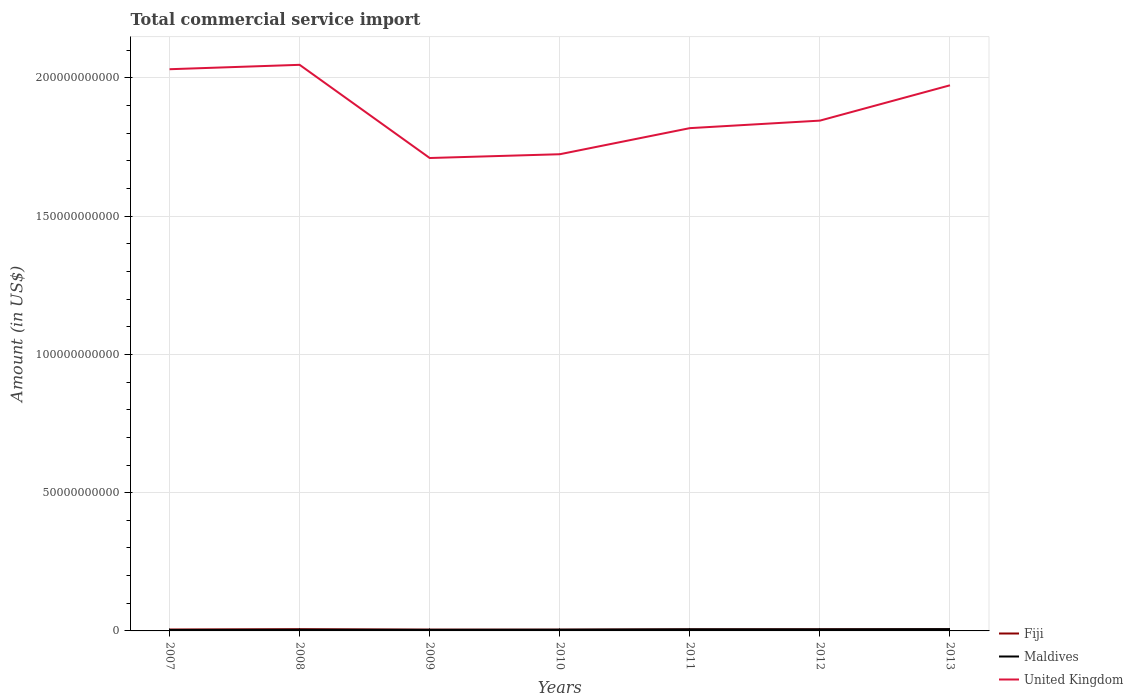How many different coloured lines are there?
Make the answer very short. 3. Is the number of lines equal to the number of legend labels?
Offer a terse response. Yes. Across all years, what is the maximum total commercial service import in Fiji?
Keep it short and to the point. 4.44e+08. In which year was the total commercial service import in United Kingdom maximum?
Your answer should be very brief. 2009. What is the total total commercial service import in United Kingdom in the graph?
Offer a terse response. 3.21e+1. What is the difference between the highest and the second highest total commercial service import in Fiji?
Provide a short and direct response. 1.78e+08. What is the difference between the highest and the lowest total commercial service import in Maldives?
Your answer should be very brief. 3. How many years are there in the graph?
Offer a terse response. 7. What is the difference between two consecutive major ticks on the Y-axis?
Give a very brief answer. 5.00e+1. Are the values on the major ticks of Y-axis written in scientific E-notation?
Offer a terse response. No. Where does the legend appear in the graph?
Offer a very short reply. Bottom right. How many legend labels are there?
Keep it short and to the point. 3. What is the title of the graph?
Provide a short and direct response. Total commercial service import. Does "Hungary" appear as one of the legend labels in the graph?
Keep it short and to the point. No. What is the label or title of the X-axis?
Provide a short and direct response. Years. What is the Amount (in US$) of Fiji in 2007?
Provide a succinct answer. 5.15e+08. What is the Amount (in US$) in Maldives in 2007?
Ensure brevity in your answer.  3.26e+08. What is the Amount (in US$) in United Kingdom in 2007?
Your response must be concise. 2.03e+11. What is the Amount (in US$) of Fiji in 2008?
Your answer should be compact. 6.22e+08. What is the Amount (in US$) in Maldives in 2008?
Your answer should be compact. 4.19e+08. What is the Amount (in US$) in United Kingdom in 2008?
Ensure brevity in your answer.  2.05e+11. What is the Amount (in US$) of Fiji in 2009?
Offer a terse response. 4.62e+08. What is the Amount (in US$) in Maldives in 2009?
Your response must be concise. 3.94e+08. What is the Amount (in US$) of United Kingdom in 2009?
Your answer should be compact. 1.71e+11. What is the Amount (in US$) of Fiji in 2010?
Your answer should be compact. 4.44e+08. What is the Amount (in US$) of Maldives in 2010?
Keep it short and to the point. 4.46e+08. What is the Amount (in US$) in United Kingdom in 2010?
Offer a very short reply. 1.72e+11. What is the Amount (in US$) of Fiji in 2011?
Ensure brevity in your answer.  5.33e+08. What is the Amount (in US$) of Maldives in 2011?
Your answer should be very brief. 5.84e+08. What is the Amount (in US$) in United Kingdom in 2011?
Your answer should be very brief. 1.82e+11. What is the Amount (in US$) of Fiji in 2012?
Keep it short and to the point. 5.62e+08. What is the Amount (in US$) in Maldives in 2012?
Your answer should be very brief. 5.72e+08. What is the Amount (in US$) of United Kingdom in 2012?
Your answer should be compact. 1.85e+11. What is the Amount (in US$) of Fiji in 2013?
Offer a terse response. 5.51e+08. What is the Amount (in US$) of Maldives in 2013?
Your response must be concise. 6.48e+08. What is the Amount (in US$) in United Kingdom in 2013?
Your answer should be very brief. 1.97e+11. Across all years, what is the maximum Amount (in US$) in Fiji?
Your answer should be very brief. 6.22e+08. Across all years, what is the maximum Amount (in US$) of Maldives?
Make the answer very short. 6.48e+08. Across all years, what is the maximum Amount (in US$) of United Kingdom?
Give a very brief answer. 2.05e+11. Across all years, what is the minimum Amount (in US$) of Fiji?
Provide a short and direct response. 4.44e+08. Across all years, what is the minimum Amount (in US$) in Maldives?
Provide a short and direct response. 3.26e+08. Across all years, what is the minimum Amount (in US$) in United Kingdom?
Your answer should be very brief. 1.71e+11. What is the total Amount (in US$) of Fiji in the graph?
Keep it short and to the point. 3.69e+09. What is the total Amount (in US$) in Maldives in the graph?
Offer a terse response. 3.39e+09. What is the total Amount (in US$) in United Kingdom in the graph?
Your answer should be very brief. 1.31e+12. What is the difference between the Amount (in US$) of Fiji in 2007 and that in 2008?
Ensure brevity in your answer.  -1.07e+08. What is the difference between the Amount (in US$) of Maldives in 2007 and that in 2008?
Offer a very short reply. -9.31e+07. What is the difference between the Amount (in US$) of United Kingdom in 2007 and that in 2008?
Provide a succinct answer. -1.59e+09. What is the difference between the Amount (in US$) in Fiji in 2007 and that in 2009?
Make the answer very short. 5.35e+07. What is the difference between the Amount (in US$) in Maldives in 2007 and that in 2009?
Offer a very short reply. -6.78e+07. What is the difference between the Amount (in US$) in United Kingdom in 2007 and that in 2009?
Provide a succinct answer. 3.21e+1. What is the difference between the Amount (in US$) of Fiji in 2007 and that in 2010?
Keep it short and to the point. 7.09e+07. What is the difference between the Amount (in US$) in Maldives in 2007 and that in 2010?
Ensure brevity in your answer.  -1.20e+08. What is the difference between the Amount (in US$) of United Kingdom in 2007 and that in 2010?
Your response must be concise. 3.07e+1. What is the difference between the Amount (in US$) of Fiji in 2007 and that in 2011?
Give a very brief answer. -1.78e+07. What is the difference between the Amount (in US$) in Maldives in 2007 and that in 2011?
Keep it short and to the point. -2.58e+08. What is the difference between the Amount (in US$) of United Kingdom in 2007 and that in 2011?
Your response must be concise. 2.13e+1. What is the difference between the Amount (in US$) in Fiji in 2007 and that in 2012?
Keep it short and to the point. -4.65e+07. What is the difference between the Amount (in US$) in Maldives in 2007 and that in 2012?
Your answer should be very brief. -2.46e+08. What is the difference between the Amount (in US$) of United Kingdom in 2007 and that in 2012?
Make the answer very short. 1.86e+1. What is the difference between the Amount (in US$) of Fiji in 2007 and that in 2013?
Offer a terse response. -3.51e+07. What is the difference between the Amount (in US$) of Maldives in 2007 and that in 2013?
Give a very brief answer. -3.21e+08. What is the difference between the Amount (in US$) in United Kingdom in 2007 and that in 2013?
Give a very brief answer. 5.81e+09. What is the difference between the Amount (in US$) of Fiji in 2008 and that in 2009?
Provide a succinct answer. 1.60e+08. What is the difference between the Amount (in US$) in Maldives in 2008 and that in 2009?
Make the answer very short. 2.53e+07. What is the difference between the Amount (in US$) in United Kingdom in 2008 and that in 2009?
Offer a terse response. 3.37e+1. What is the difference between the Amount (in US$) in Fiji in 2008 and that in 2010?
Offer a terse response. 1.78e+08. What is the difference between the Amount (in US$) of Maldives in 2008 and that in 2010?
Ensure brevity in your answer.  -2.64e+07. What is the difference between the Amount (in US$) in United Kingdom in 2008 and that in 2010?
Provide a succinct answer. 3.23e+1. What is the difference between the Amount (in US$) of Fiji in 2008 and that in 2011?
Your answer should be very brief. 8.88e+07. What is the difference between the Amount (in US$) of Maldives in 2008 and that in 2011?
Make the answer very short. -1.65e+08. What is the difference between the Amount (in US$) in United Kingdom in 2008 and that in 2011?
Provide a short and direct response. 2.29e+1. What is the difference between the Amount (in US$) of Fiji in 2008 and that in 2012?
Offer a terse response. 6.02e+07. What is the difference between the Amount (in US$) in Maldives in 2008 and that in 2012?
Offer a terse response. -1.53e+08. What is the difference between the Amount (in US$) in United Kingdom in 2008 and that in 2012?
Your response must be concise. 2.02e+1. What is the difference between the Amount (in US$) of Fiji in 2008 and that in 2013?
Your answer should be very brief. 7.15e+07. What is the difference between the Amount (in US$) in Maldives in 2008 and that in 2013?
Your answer should be very brief. -2.28e+08. What is the difference between the Amount (in US$) in United Kingdom in 2008 and that in 2013?
Offer a very short reply. 7.40e+09. What is the difference between the Amount (in US$) of Fiji in 2009 and that in 2010?
Your response must be concise. 1.74e+07. What is the difference between the Amount (in US$) of Maldives in 2009 and that in 2010?
Your response must be concise. -5.18e+07. What is the difference between the Amount (in US$) of United Kingdom in 2009 and that in 2010?
Your answer should be very brief. -1.37e+09. What is the difference between the Amount (in US$) of Fiji in 2009 and that in 2011?
Keep it short and to the point. -7.13e+07. What is the difference between the Amount (in US$) in Maldives in 2009 and that in 2011?
Your answer should be compact. -1.90e+08. What is the difference between the Amount (in US$) in United Kingdom in 2009 and that in 2011?
Your answer should be compact. -1.08e+1. What is the difference between the Amount (in US$) in Fiji in 2009 and that in 2012?
Your response must be concise. -1.00e+08. What is the difference between the Amount (in US$) in Maldives in 2009 and that in 2012?
Your answer should be compact. -1.78e+08. What is the difference between the Amount (in US$) of United Kingdom in 2009 and that in 2012?
Your answer should be compact. -1.35e+1. What is the difference between the Amount (in US$) of Fiji in 2009 and that in 2013?
Offer a very short reply. -8.86e+07. What is the difference between the Amount (in US$) in Maldives in 2009 and that in 2013?
Your answer should be very brief. -2.53e+08. What is the difference between the Amount (in US$) in United Kingdom in 2009 and that in 2013?
Your response must be concise. -2.63e+1. What is the difference between the Amount (in US$) in Fiji in 2010 and that in 2011?
Ensure brevity in your answer.  -8.88e+07. What is the difference between the Amount (in US$) of Maldives in 2010 and that in 2011?
Make the answer very short. -1.38e+08. What is the difference between the Amount (in US$) in United Kingdom in 2010 and that in 2011?
Your response must be concise. -9.43e+09. What is the difference between the Amount (in US$) of Fiji in 2010 and that in 2012?
Offer a very short reply. -1.17e+08. What is the difference between the Amount (in US$) in Maldives in 2010 and that in 2012?
Provide a short and direct response. -1.26e+08. What is the difference between the Amount (in US$) of United Kingdom in 2010 and that in 2012?
Provide a short and direct response. -1.22e+1. What is the difference between the Amount (in US$) in Fiji in 2010 and that in 2013?
Ensure brevity in your answer.  -1.06e+08. What is the difference between the Amount (in US$) in Maldives in 2010 and that in 2013?
Give a very brief answer. -2.02e+08. What is the difference between the Amount (in US$) in United Kingdom in 2010 and that in 2013?
Your response must be concise. -2.49e+1. What is the difference between the Amount (in US$) of Fiji in 2011 and that in 2012?
Ensure brevity in your answer.  -2.86e+07. What is the difference between the Amount (in US$) of Maldives in 2011 and that in 2012?
Your answer should be compact. 1.19e+07. What is the difference between the Amount (in US$) in United Kingdom in 2011 and that in 2012?
Keep it short and to the point. -2.72e+09. What is the difference between the Amount (in US$) of Fiji in 2011 and that in 2013?
Offer a terse response. -1.73e+07. What is the difference between the Amount (in US$) in Maldives in 2011 and that in 2013?
Your response must be concise. -6.36e+07. What is the difference between the Amount (in US$) in United Kingdom in 2011 and that in 2013?
Provide a short and direct response. -1.55e+1. What is the difference between the Amount (in US$) of Fiji in 2012 and that in 2013?
Your answer should be compact. 1.14e+07. What is the difference between the Amount (in US$) in Maldives in 2012 and that in 2013?
Your response must be concise. -7.55e+07. What is the difference between the Amount (in US$) of United Kingdom in 2012 and that in 2013?
Give a very brief answer. -1.28e+1. What is the difference between the Amount (in US$) of Fiji in 2007 and the Amount (in US$) of Maldives in 2008?
Your answer should be very brief. 9.59e+07. What is the difference between the Amount (in US$) in Fiji in 2007 and the Amount (in US$) in United Kingdom in 2008?
Keep it short and to the point. -2.04e+11. What is the difference between the Amount (in US$) in Maldives in 2007 and the Amount (in US$) in United Kingdom in 2008?
Offer a terse response. -2.04e+11. What is the difference between the Amount (in US$) of Fiji in 2007 and the Amount (in US$) of Maldives in 2009?
Offer a very short reply. 1.21e+08. What is the difference between the Amount (in US$) in Fiji in 2007 and the Amount (in US$) in United Kingdom in 2009?
Provide a succinct answer. -1.71e+11. What is the difference between the Amount (in US$) in Maldives in 2007 and the Amount (in US$) in United Kingdom in 2009?
Keep it short and to the point. -1.71e+11. What is the difference between the Amount (in US$) of Fiji in 2007 and the Amount (in US$) of Maldives in 2010?
Your response must be concise. 6.95e+07. What is the difference between the Amount (in US$) of Fiji in 2007 and the Amount (in US$) of United Kingdom in 2010?
Your answer should be compact. -1.72e+11. What is the difference between the Amount (in US$) in Maldives in 2007 and the Amount (in US$) in United Kingdom in 2010?
Provide a succinct answer. -1.72e+11. What is the difference between the Amount (in US$) of Fiji in 2007 and the Amount (in US$) of Maldives in 2011?
Keep it short and to the point. -6.86e+07. What is the difference between the Amount (in US$) in Fiji in 2007 and the Amount (in US$) in United Kingdom in 2011?
Provide a succinct answer. -1.81e+11. What is the difference between the Amount (in US$) of Maldives in 2007 and the Amount (in US$) of United Kingdom in 2011?
Offer a very short reply. -1.81e+11. What is the difference between the Amount (in US$) of Fiji in 2007 and the Amount (in US$) of Maldives in 2012?
Your answer should be very brief. -5.66e+07. What is the difference between the Amount (in US$) of Fiji in 2007 and the Amount (in US$) of United Kingdom in 2012?
Offer a very short reply. -1.84e+11. What is the difference between the Amount (in US$) of Maldives in 2007 and the Amount (in US$) of United Kingdom in 2012?
Give a very brief answer. -1.84e+11. What is the difference between the Amount (in US$) of Fiji in 2007 and the Amount (in US$) of Maldives in 2013?
Your answer should be very brief. -1.32e+08. What is the difference between the Amount (in US$) in Fiji in 2007 and the Amount (in US$) in United Kingdom in 2013?
Provide a short and direct response. -1.97e+11. What is the difference between the Amount (in US$) of Maldives in 2007 and the Amount (in US$) of United Kingdom in 2013?
Keep it short and to the point. -1.97e+11. What is the difference between the Amount (in US$) in Fiji in 2008 and the Amount (in US$) in Maldives in 2009?
Provide a succinct answer. 2.28e+08. What is the difference between the Amount (in US$) of Fiji in 2008 and the Amount (in US$) of United Kingdom in 2009?
Your answer should be compact. -1.70e+11. What is the difference between the Amount (in US$) in Maldives in 2008 and the Amount (in US$) in United Kingdom in 2009?
Your answer should be very brief. -1.71e+11. What is the difference between the Amount (in US$) in Fiji in 2008 and the Amount (in US$) in Maldives in 2010?
Give a very brief answer. 1.76e+08. What is the difference between the Amount (in US$) of Fiji in 2008 and the Amount (in US$) of United Kingdom in 2010?
Offer a very short reply. -1.72e+11. What is the difference between the Amount (in US$) in Maldives in 2008 and the Amount (in US$) in United Kingdom in 2010?
Provide a succinct answer. -1.72e+11. What is the difference between the Amount (in US$) of Fiji in 2008 and the Amount (in US$) of Maldives in 2011?
Offer a terse response. 3.81e+07. What is the difference between the Amount (in US$) of Fiji in 2008 and the Amount (in US$) of United Kingdom in 2011?
Your answer should be compact. -1.81e+11. What is the difference between the Amount (in US$) in Maldives in 2008 and the Amount (in US$) in United Kingdom in 2011?
Offer a very short reply. -1.81e+11. What is the difference between the Amount (in US$) in Fiji in 2008 and the Amount (in US$) in Maldives in 2012?
Your answer should be compact. 5.00e+07. What is the difference between the Amount (in US$) in Fiji in 2008 and the Amount (in US$) in United Kingdom in 2012?
Ensure brevity in your answer.  -1.84e+11. What is the difference between the Amount (in US$) in Maldives in 2008 and the Amount (in US$) in United Kingdom in 2012?
Offer a terse response. -1.84e+11. What is the difference between the Amount (in US$) in Fiji in 2008 and the Amount (in US$) in Maldives in 2013?
Your answer should be very brief. -2.55e+07. What is the difference between the Amount (in US$) in Fiji in 2008 and the Amount (in US$) in United Kingdom in 2013?
Offer a terse response. -1.97e+11. What is the difference between the Amount (in US$) in Maldives in 2008 and the Amount (in US$) in United Kingdom in 2013?
Keep it short and to the point. -1.97e+11. What is the difference between the Amount (in US$) of Fiji in 2009 and the Amount (in US$) of Maldives in 2010?
Your answer should be compact. 1.60e+07. What is the difference between the Amount (in US$) in Fiji in 2009 and the Amount (in US$) in United Kingdom in 2010?
Provide a short and direct response. -1.72e+11. What is the difference between the Amount (in US$) of Maldives in 2009 and the Amount (in US$) of United Kingdom in 2010?
Your answer should be very brief. -1.72e+11. What is the difference between the Amount (in US$) in Fiji in 2009 and the Amount (in US$) in Maldives in 2011?
Make the answer very short. -1.22e+08. What is the difference between the Amount (in US$) in Fiji in 2009 and the Amount (in US$) in United Kingdom in 2011?
Keep it short and to the point. -1.81e+11. What is the difference between the Amount (in US$) of Maldives in 2009 and the Amount (in US$) of United Kingdom in 2011?
Ensure brevity in your answer.  -1.81e+11. What is the difference between the Amount (in US$) in Fiji in 2009 and the Amount (in US$) in Maldives in 2012?
Give a very brief answer. -1.10e+08. What is the difference between the Amount (in US$) of Fiji in 2009 and the Amount (in US$) of United Kingdom in 2012?
Your answer should be very brief. -1.84e+11. What is the difference between the Amount (in US$) of Maldives in 2009 and the Amount (in US$) of United Kingdom in 2012?
Your answer should be very brief. -1.84e+11. What is the difference between the Amount (in US$) in Fiji in 2009 and the Amount (in US$) in Maldives in 2013?
Your answer should be compact. -1.86e+08. What is the difference between the Amount (in US$) of Fiji in 2009 and the Amount (in US$) of United Kingdom in 2013?
Offer a very short reply. -1.97e+11. What is the difference between the Amount (in US$) of Maldives in 2009 and the Amount (in US$) of United Kingdom in 2013?
Offer a terse response. -1.97e+11. What is the difference between the Amount (in US$) of Fiji in 2010 and the Amount (in US$) of Maldives in 2011?
Provide a short and direct response. -1.39e+08. What is the difference between the Amount (in US$) in Fiji in 2010 and the Amount (in US$) in United Kingdom in 2011?
Your answer should be compact. -1.81e+11. What is the difference between the Amount (in US$) of Maldives in 2010 and the Amount (in US$) of United Kingdom in 2011?
Provide a short and direct response. -1.81e+11. What is the difference between the Amount (in US$) of Fiji in 2010 and the Amount (in US$) of Maldives in 2012?
Make the answer very short. -1.28e+08. What is the difference between the Amount (in US$) of Fiji in 2010 and the Amount (in US$) of United Kingdom in 2012?
Give a very brief answer. -1.84e+11. What is the difference between the Amount (in US$) in Maldives in 2010 and the Amount (in US$) in United Kingdom in 2012?
Offer a very short reply. -1.84e+11. What is the difference between the Amount (in US$) of Fiji in 2010 and the Amount (in US$) of Maldives in 2013?
Your answer should be very brief. -2.03e+08. What is the difference between the Amount (in US$) in Fiji in 2010 and the Amount (in US$) in United Kingdom in 2013?
Make the answer very short. -1.97e+11. What is the difference between the Amount (in US$) of Maldives in 2010 and the Amount (in US$) of United Kingdom in 2013?
Provide a short and direct response. -1.97e+11. What is the difference between the Amount (in US$) of Fiji in 2011 and the Amount (in US$) of Maldives in 2012?
Ensure brevity in your answer.  -3.88e+07. What is the difference between the Amount (in US$) of Fiji in 2011 and the Amount (in US$) of United Kingdom in 2012?
Make the answer very short. -1.84e+11. What is the difference between the Amount (in US$) in Maldives in 2011 and the Amount (in US$) in United Kingdom in 2012?
Keep it short and to the point. -1.84e+11. What is the difference between the Amount (in US$) of Fiji in 2011 and the Amount (in US$) of Maldives in 2013?
Ensure brevity in your answer.  -1.14e+08. What is the difference between the Amount (in US$) of Fiji in 2011 and the Amount (in US$) of United Kingdom in 2013?
Offer a very short reply. -1.97e+11. What is the difference between the Amount (in US$) in Maldives in 2011 and the Amount (in US$) in United Kingdom in 2013?
Ensure brevity in your answer.  -1.97e+11. What is the difference between the Amount (in US$) of Fiji in 2012 and the Amount (in US$) of Maldives in 2013?
Offer a very short reply. -8.57e+07. What is the difference between the Amount (in US$) of Fiji in 2012 and the Amount (in US$) of United Kingdom in 2013?
Your answer should be very brief. -1.97e+11. What is the difference between the Amount (in US$) in Maldives in 2012 and the Amount (in US$) in United Kingdom in 2013?
Your answer should be very brief. -1.97e+11. What is the average Amount (in US$) in Fiji per year?
Make the answer very short. 5.27e+08. What is the average Amount (in US$) in Maldives per year?
Your response must be concise. 4.84e+08. What is the average Amount (in US$) of United Kingdom per year?
Your answer should be very brief. 1.88e+11. In the year 2007, what is the difference between the Amount (in US$) in Fiji and Amount (in US$) in Maldives?
Give a very brief answer. 1.89e+08. In the year 2007, what is the difference between the Amount (in US$) of Fiji and Amount (in US$) of United Kingdom?
Give a very brief answer. -2.03e+11. In the year 2007, what is the difference between the Amount (in US$) in Maldives and Amount (in US$) in United Kingdom?
Offer a terse response. -2.03e+11. In the year 2008, what is the difference between the Amount (in US$) of Fiji and Amount (in US$) of Maldives?
Keep it short and to the point. 2.03e+08. In the year 2008, what is the difference between the Amount (in US$) in Fiji and Amount (in US$) in United Kingdom?
Provide a succinct answer. -2.04e+11. In the year 2008, what is the difference between the Amount (in US$) in Maldives and Amount (in US$) in United Kingdom?
Give a very brief answer. -2.04e+11. In the year 2009, what is the difference between the Amount (in US$) in Fiji and Amount (in US$) in Maldives?
Make the answer very short. 6.78e+07. In the year 2009, what is the difference between the Amount (in US$) in Fiji and Amount (in US$) in United Kingdom?
Your answer should be compact. -1.71e+11. In the year 2009, what is the difference between the Amount (in US$) of Maldives and Amount (in US$) of United Kingdom?
Your response must be concise. -1.71e+11. In the year 2010, what is the difference between the Amount (in US$) of Fiji and Amount (in US$) of Maldives?
Keep it short and to the point. -1.44e+06. In the year 2010, what is the difference between the Amount (in US$) in Fiji and Amount (in US$) in United Kingdom?
Offer a terse response. -1.72e+11. In the year 2010, what is the difference between the Amount (in US$) of Maldives and Amount (in US$) of United Kingdom?
Offer a terse response. -1.72e+11. In the year 2011, what is the difference between the Amount (in US$) of Fiji and Amount (in US$) of Maldives?
Ensure brevity in your answer.  -5.07e+07. In the year 2011, what is the difference between the Amount (in US$) of Fiji and Amount (in US$) of United Kingdom?
Your response must be concise. -1.81e+11. In the year 2011, what is the difference between the Amount (in US$) of Maldives and Amount (in US$) of United Kingdom?
Your answer should be very brief. -1.81e+11. In the year 2012, what is the difference between the Amount (in US$) of Fiji and Amount (in US$) of Maldives?
Give a very brief answer. -1.02e+07. In the year 2012, what is the difference between the Amount (in US$) of Fiji and Amount (in US$) of United Kingdom?
Keep it short and to the point. -1.84e+11. In the year 2012, what is the difference between the Amount (in US$) in Maldives and Amount (in US$) in United Kingdom?
Give a very brief answer. -1.84e+11. In the year 2013, what is the difference between the Amount (in US$) in Fiji and Amount (in US$) in Maldives?
Your answer should be very brief. -9.71e+07. In the year 2013, what is the difference between the Amount (in US$) in Fiji and Amount (in US$) in United Kingdom?
Offer a terse response. -1.97e+11. In the year 2013, what is the difference between the Amount (in US$) of Maldives and Amount (in US$) of United Kingdom?
Your answer should be very brief. -1.97e+11. What is the ratio of the Amount (in US$) of Fiji in 2007 to that in 2008?
Your answer should be very brief. 0.83. What is the ratio of the Amount (in US$) in Maldives in 2007 to that in 2008?
Make the answer very short. 0.78. What is the ratio of the Amount (in US$) of United Kingdom in 2007 to that in 2008?
Offer a very short reply. 0.99. What is the ratio of the Amount (in US$) in Fiji in 2007 to that in 2009?
Keep it short and to the point. 1.12. What is the ratio of the Amount (in US$) in Maldives in 2007 to that in 2009?
Your response must be concise. 0.83. What is the ratio of the Amount (in US$) of United Kingdom in 2007 to that in 2009?
Ensure brevity in your answer.  1.19. What is the ratio of the Amount (in US$) in Fiji in 2007 to that in 2010?
Provide a succinct answer. 1.16. What is the ratio of the Amount (in US$) in Maldives in 2007 to that in 2010?
Ensure brevity in your answer.  0.73. What is the ratio of the Amount (in US$) in United Kingdom in 2007 to that in 2010?
Make the answer very short. 1.18. What is the ratio of the Amount (in US$) in Fiji in 2007 to that in 2011?
Ensure brevity in your answer.  0.97. What is the ratio of the Amount (in US$) in Maldives in 2007 to that in 2011?
Give a very brief answer. 0.56. What is the ratio of the Amount (in US$) of United Kingdom in 2007 to that in 2011?
Offer a very short reply. 1.12. What is the ratio of the Amount (in US$) of Fiji in 2007 to that in 2012?
Make the answer very short. 0.92. What is the ratio of the Amount (in US$) in Maldives in 2007 to that in 2012?
Your answer should be very brief. 0.57. What is the ratio of the Amount (in US$) of United Kingdom in 2007 to that in 2012?
Make the answer very short. 1.1. What is the ratio of the Amount (in US$) of Fiji in 2007 to that in 2013?
Your response must be concise. 0.94. What is the ratio of the Amount (in US$) of Maldives in 2007 to that in 2013?
Keep it short and to the point. 0.5. What is the ratio of the Amount (in US$) of United Kingdom in 2007 to that in 2013?
Ensure brevity in your answer.  1.03. What is the ratio of the Amount (in US$) of Fiji in 2008 to that in 2009?
Give a very brief answer. 1.35. What is the ratio of the Amount (in US$) of Maldives in 2008 to that in 2009?
Ensure brevity in your answer.  1.06. What is the ratio of the Amount (in US$) of United Kingdom in 2008 to that in 2009?
Provide a succinct answer. 1.2. What is the ratio of the Amount (in US$) of Fiji in 2008 to that in 2010?
Offer a very short reply. 1.4. What is the ratio of the Amount (in US$) of Maldives in 2008 to that in 2010?
Your response must be concise. 0.94. What is the ratio of the Amount (in US$) of United Kingdom in 2008 to that in 2010?
Offer a terse response. 1.19. What is the ratio of the Amount (in US$) of Fiji in 2008 to that in 2011?
Provide a succinct answer. 1.17. What is the ratio of the Amount (in US$) of Maldives in 2008 to that in 2011?
Make the answer very short. 0.72. What is the ratio of the Amount (in US$) of United Kingdom in 2008 to that in 2011?
Your response must be concise. 1.13. What is the ratio of the Amount (in US$) of Fiji in 2008 to that in 2012?
Provide a short and direct response. 1.11. What is the ratio of the Amount (in US$) in Maldives in 2008 to that in 2012?
Provide a short and direct response. 0.73. What is the ratio of the Amount (in US$) in United Kingdom in 2008 to that in 2012?
Ensure brevity in your answer.  1.11. What is the ratio of the Amount (in US$) in Fiji in 2008 to that in 2013?
Your answer should be very brief. 1.13. What is the ratio of the Amount (in US$) in Maldives in 2008 to that in 2013?
Provide a succinct answer. 0.65. What is the ratio of the Amount (in US$) of United Kingdom in 2008 to that in 2013?
Your answer should be very brief. 1.04. What is the ratio of the Amount (in US$) in Fiji in 2009 to that in 2010?
Ensure brevity in your answer.  1.04. What is the ratio of the Amount (in US$) of Maldives in 2009 to that in 2010?
Provide a succinct answer. 0.88. What is the ratio of the Amount (in US$) in United Kingdom in 2009 to that in 2010?
Your answer should be compact. 0.99. What is the ratio of the Amount (in US$) of Fiji in 2009 to that in 2011?
Give a very brief answer. 0.87. What is the ratio of the Amount (in US$) in Maldives in 2009 to that in 2011?
Provide a short and direct response. 0.67. What is the ratio of the Amount (in US$) in United Kingdom in 2009 to that in 2011?
Offer a very short reply. 0.94. What is the ratio of the Amount (in US$) in Fiji in 2009 to that in 2012?
Your answer should be very brief. 0.82. What is the ratio of the Amount (in US$) in Maldives in 2009 to that in 2012?
Provide a short and direct response. 0.69. What is the ratio of the Amount (in US$) in United Kingdom in 2009 to that in 2012?
Your answer should be compact. 0.93. What is the ratio of the Amount (in US$) of Fiji in 2009 to that in 2013?
Make the answer very short. 0.84. What is the ratio of the Amount (in US$) of Maldives in 2009 to that in 2013?
Provide a succinct answer. 0.61. What is the ratio of the Amount (in US$) in United Kingdom in 2009 to that in 2013?
Your answer should be very brief. 0.87. What is the ratio of the Amount (in US$) of Fiji in 2010 to that in 2011?
Offer a terse response. 0.83. What is the ratio of the Amount (in US$) in Maldives in 2010 to that in 2011?
Make the answer very short. 0.76. What is the ratio of the Amount (in US$) in United Kingdom in 2010 to that in 2011?
Make the answer very short. 0.95. What is the ratio of the Amount (in US$) in Fiji in 2010 to that in 2012?
Offer a very short reply. 0.79. What is the ratio of the Amount (in US$) in Maldives in 2010 to that in 2012?
Give a very brief answer. 0.78. What is the ratio of the Amount (in US$) of United Kingdom in 2010 to that in 2012?
Make the answer very short. 0.93. What is the ratio of the Amount (in US$) in Fiji in 2010 to that in 2013?
Offer a very short reply. 0.81. What is the ratio of the Amount (in US$) of Maldives in 2010 to that in 2013?
Provide a succinct answer. 0.69. What is the ratio of the Amount (in US$) in United Kingdom in 2010 to that in 2013?
Your answer should be compact. 0.87. What is the ratio of the Amount (in US$) in Fiji in 2011 to that in 2012?
Your answer should be compact. 0.95. What is the ratio of the Amount (in US$) in Maldives in 2011 to that in 2012?
Offer a very short reply. 1.02. What is the ratio of the Amount (in US$) of Fiji in 2011 to that in 2013?
Ensure brevity in your answer.  0.97. What is the ratio of the Amount (in US$) of Maldives in 2011 to that in 2013?
Your answer should be compact. 0.9. What is the ratio of the Amount (in US$) in United Kingdom in 2011 to that in 2013?
Offer a very short reply. 0.92. What is the ratio of the Amount (in US$) of Fiji in 2012 to that in 2013?
Ensure brevity in your answer.  1.02. What is the ratio of the Amount (in US$) of Maldives in 2012 to that in 2013?
Your answer should be compact. 0.88. What is the ratio of the Amount (in US$) in United Kingdom in 2012 to that in 2013?
Give a very brief answer. 0.94. What is the difference between the highest and the second highest Amount (in US$) of Fiji?
Ensure brevity in your answer.  6.02e+07. What is the difference between the highest and the second highest Amount (in US$) in Maldives?
Your answer should be compact. 6.36e+07. What is the difference between the highest and the second highest Amount (in US$) of United Kingdom?
Give a very brief answer. 1.59e+09. What is the difference between the highest and the lowest Amount (in US$) in Fiji?
Your response must be concise. 1.78e+08. What is the difference between the highest and the lowest Amount (in US$) of Maldives?
Offer a very short reply. 3.21e+08. What is the difference between the highest and the lowest Amount (in US$) of United Kingdom?
Provide a short and direct response. 3.37e+1. 